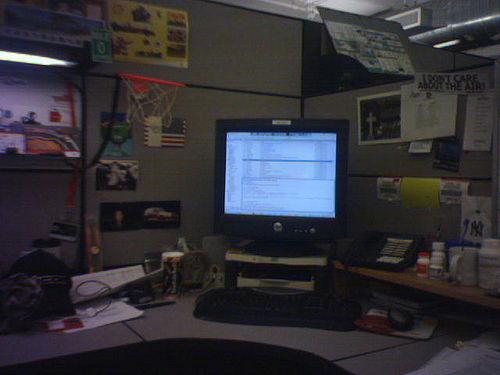How many white trucks can you see?
Give a very brief answer. 0. 